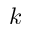<formula> <loc_0><loc_0><loc_500><loc_500>k</formula> 